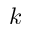<formula> <loc_0><loc_0><loc_500><loc_500>k</formula> 